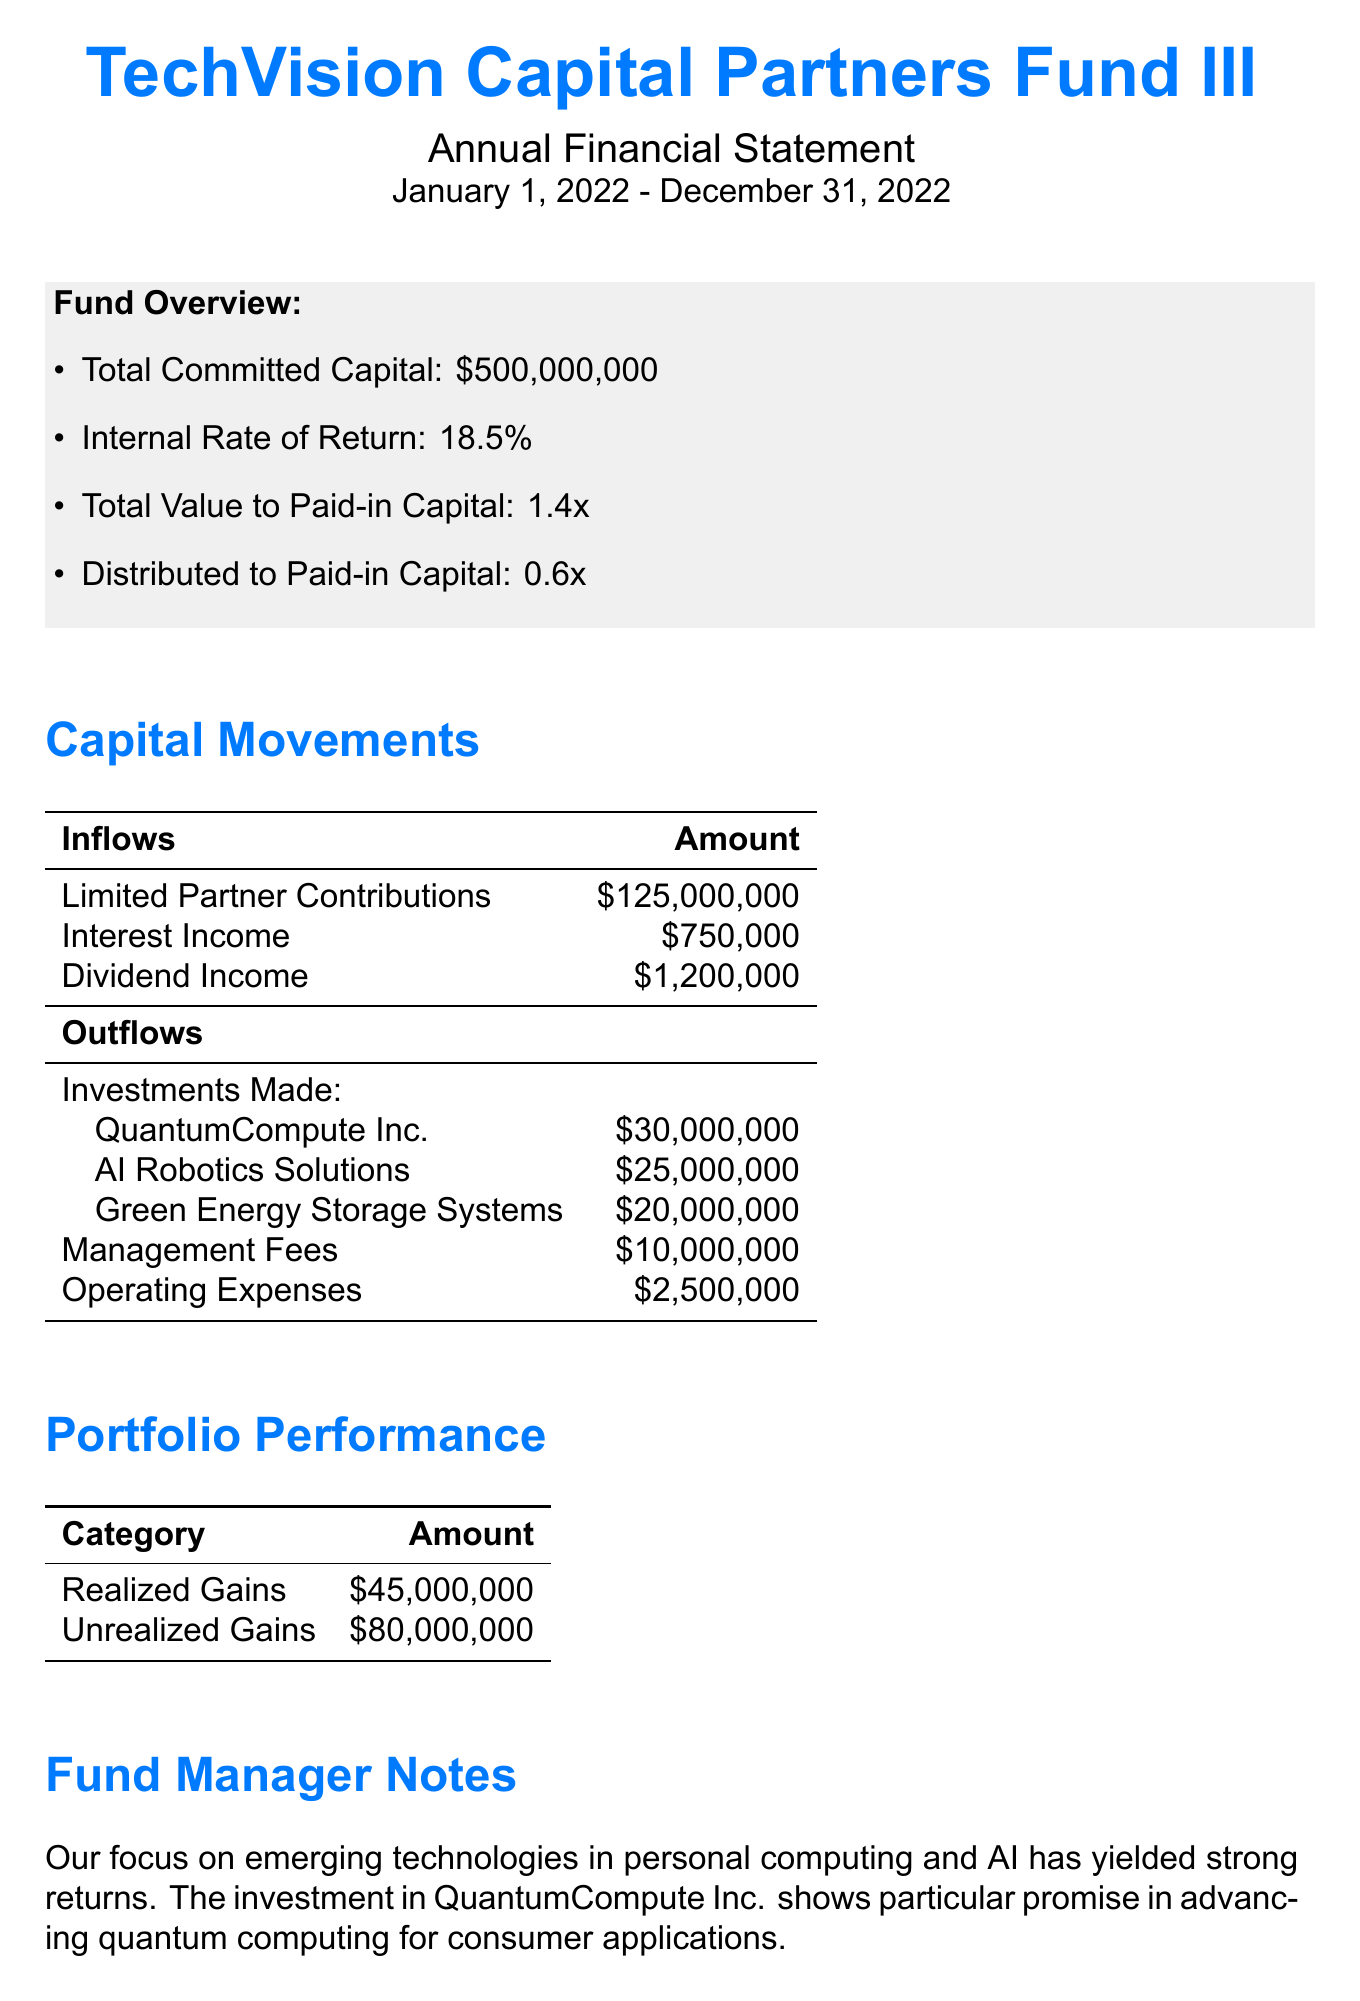What is the total committed capital? The total committed capital is provided in the document as $500,000,000.
Answer: $500,000,000 What is the internal rate of return for the fund? The internal rate of return is mentioned in the key metrics section as 18.5%.
Answer: 18.5% How much was invested in AI Robotics Solutions? The amount invested in AI Robotics Solutions can be found under the investments made section, which is $25,000,000.
Answer: $25,000,000 What are the total realized gains reported? Total realized gains are specified in the portfolio performance section, which states $45,000,000.
Answer: $45,000,000 What is the amount allocated to management fees? The management fees are listed in the capital outflows section as $10,000,000.
Answer: $10,000,000 What is the total capital inflow from limited partner contributions? The total capital inflow from limited partner contributions is stated as $125,000,000.
Answer: $125,000,000 What is the total amount of operating expenses? The total amount of operating expenses is mentioned in the capital outflows section as $2,500,000.
Answer: $2,500,000 How many investments were made by the fund? Three investments are listed under investments made in the document.
Answer: Three What is the total value to paid-in capital? The total value to paid-in capital is stated in the key metrics section as 1.4x.
Answer: 1.4x What does the fund manager note highlight? The fund manager note highlights the focus on emerging technologies in personal computing and AI.
Answer: Emerging technologies in personal computing and AI 